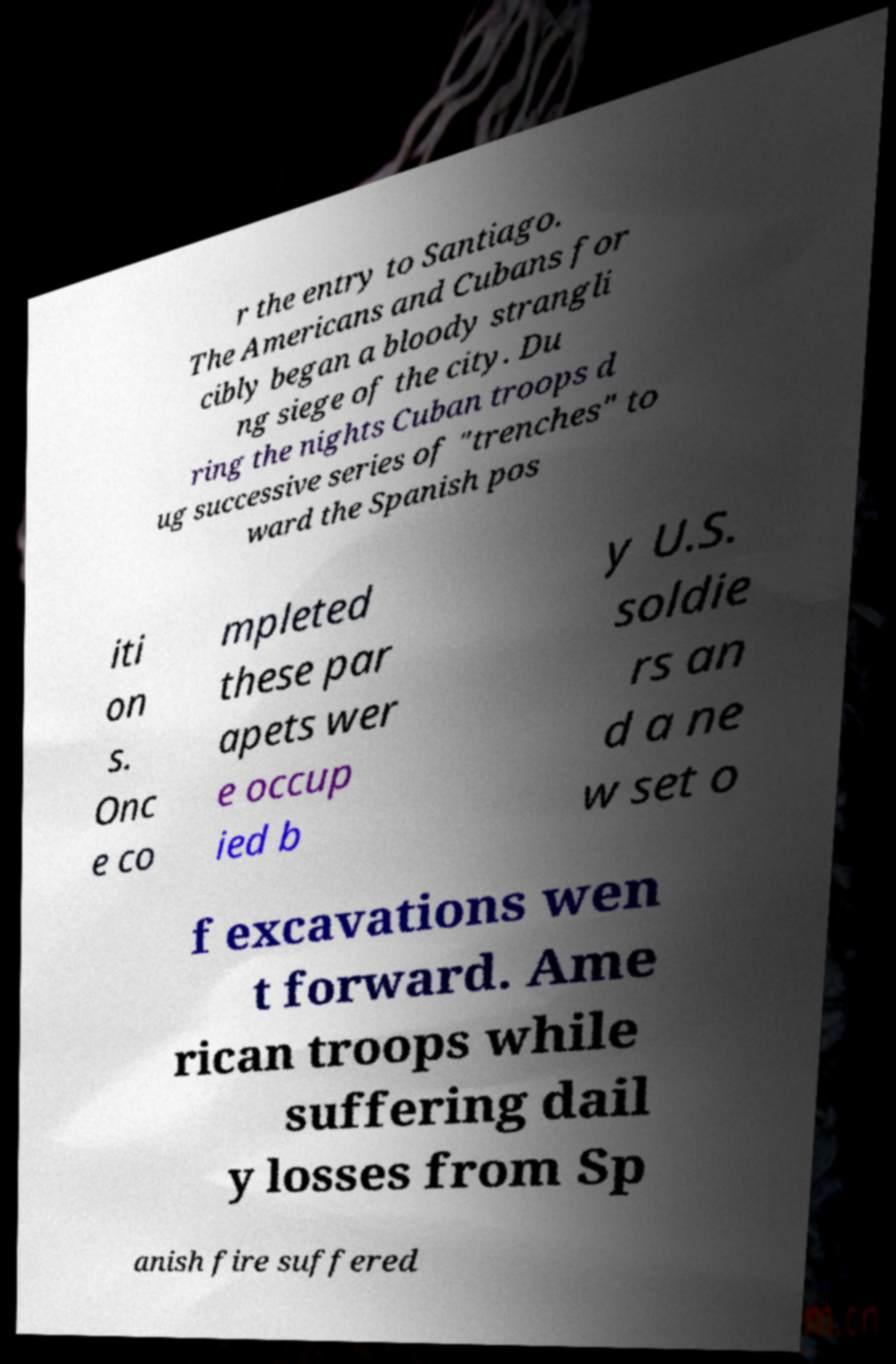Could you assist in decoding the text presented in this image and type it out clearly? r the entry to Santiago. The Americans and Cubans for cibly began a bloody strangli ng siege of the city. Du ring the nights Cuban troops d ug successive series of "trenches" to ward the Spanish pos iti on s. Onc e co mpleted these par apets wer e occup ied b y U.S. soldie rs an d a ne w set o f excavations wen t forward. Ame rican troops while suffering dail y losses from Sp anish fire suffered 